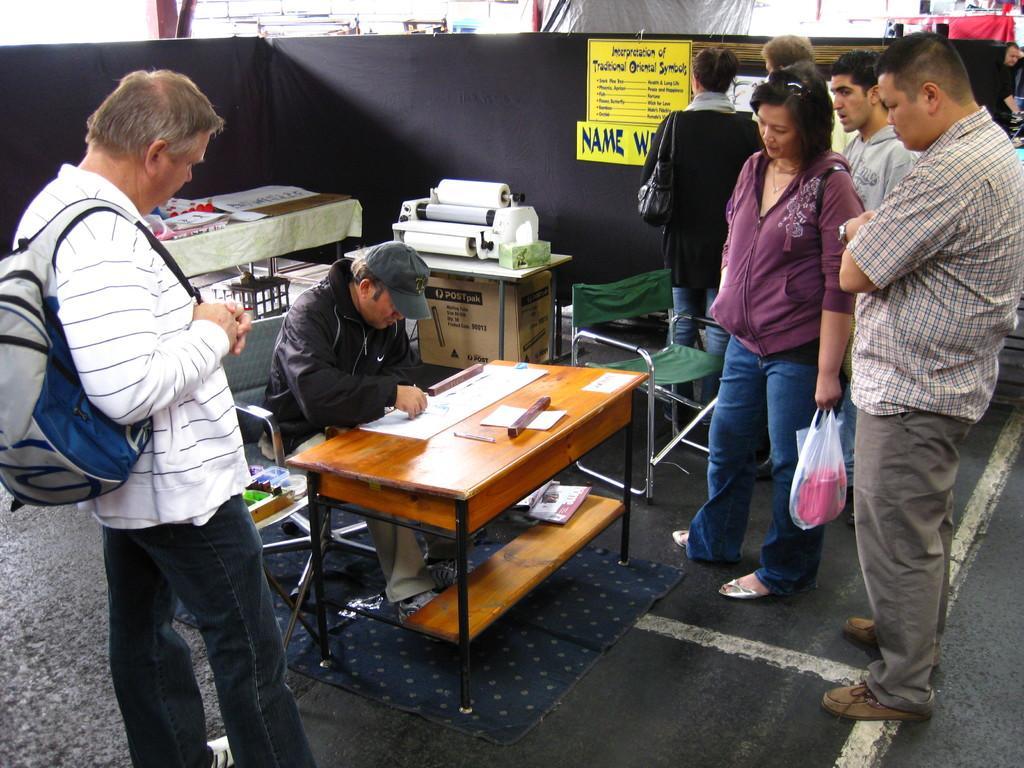How would you summarize this image in a sentence or two? This picture shows few people standing and we see a man seated on the chair and working with a paper on the table and people looking at him 